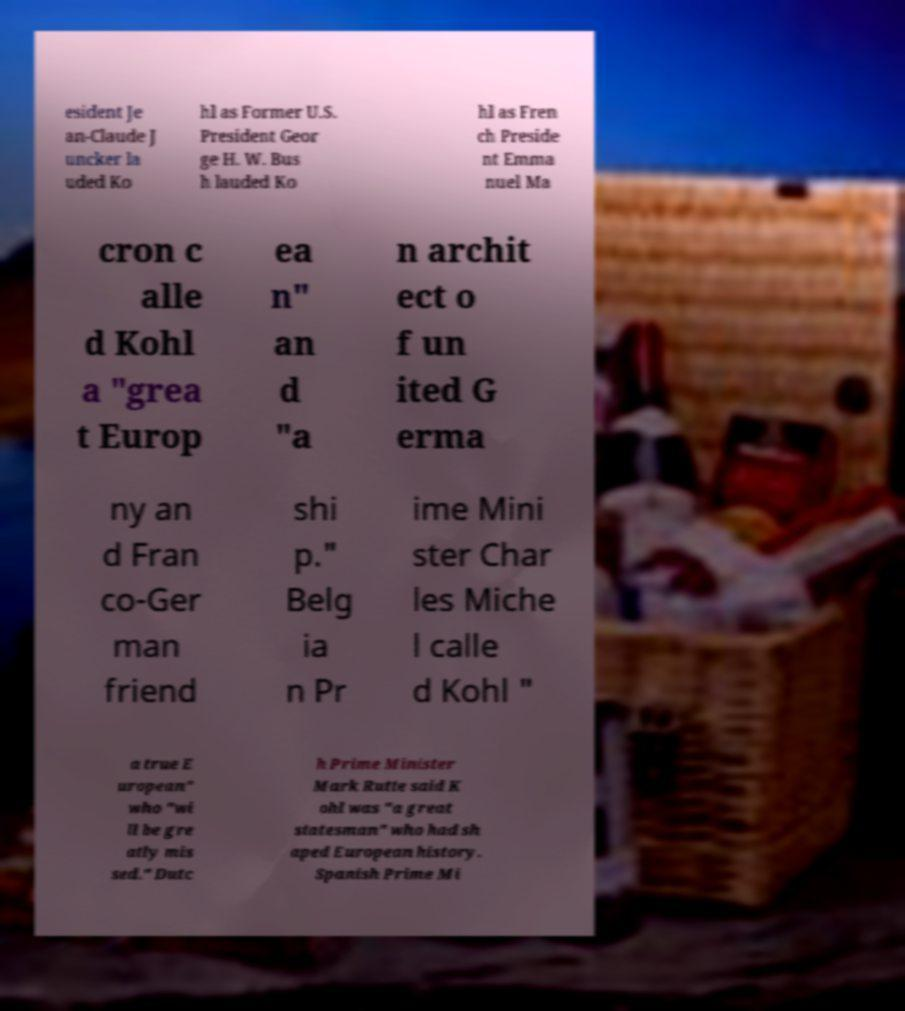Please read and relay the text visible in this image. What does it say? esident Je an-Claude J uncker la uded Ko hl as Former U.S. President Geor ge H. W. Bus h lauded Ko hl as Fren ch Preside nt Emma nuel Ma cron c alle d Kohl a "grea t Europ ea n" an d "a n archit ect o f un ited G erma ny an d Fran co-Ger man friend shi p." Belg ia n Pr ime Mini ster Char les Miche l calle d Kohl " a true E uropean" who "wi ll be gre atly mis sed." Dutc h Prime Minister Mark Rutte said K ohl was "a great statesman" who had sh aped European history. Spanish Prime Mi 